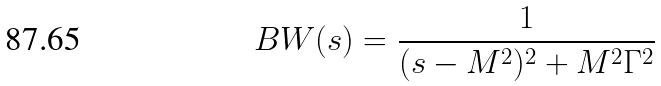<formula> <loc_0><loc_0><loc_500><loc_500>B W ( s ) = \frac { 1 } { ( s - M ^ { 2 } ) ^ { 2 } + M ^ { 2 } \Gamma ^ { 2 } }</formula> 